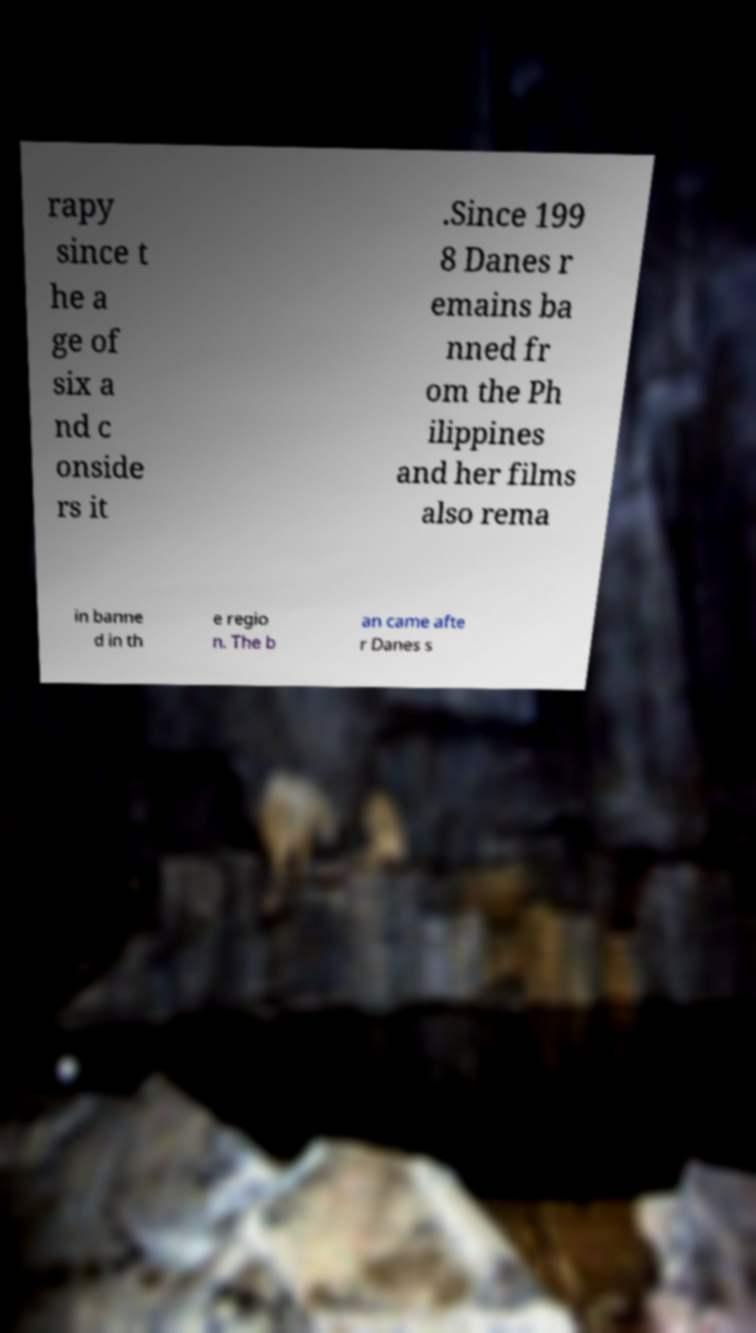Could you extract and type out the text from this image? rapy since t he a ge of six a nd c onside rs it .Since 199 8 Danes r emains ba nned fr om the Ph ilippines and her films also rema in banne d in th e regio n. The b an came afte r Danes s 